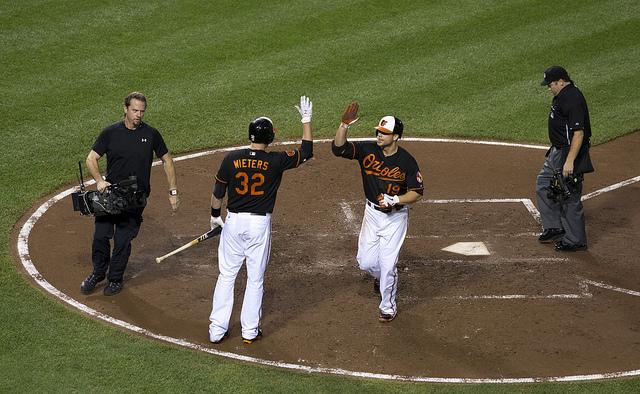Is the batter ready to bat?
Keep it brief. No. What is the number of the man with the bat?
Quick response, please. 32. What game are they playing?
Concise answer only. Baseball. 